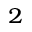<formula> <loc_0><loc_0><loc_500><loc_500>^ { 2 }</formula> 